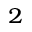<formula> <loc_0><loc_0><loc_500><loc_500>^ { 2 }</formula> 